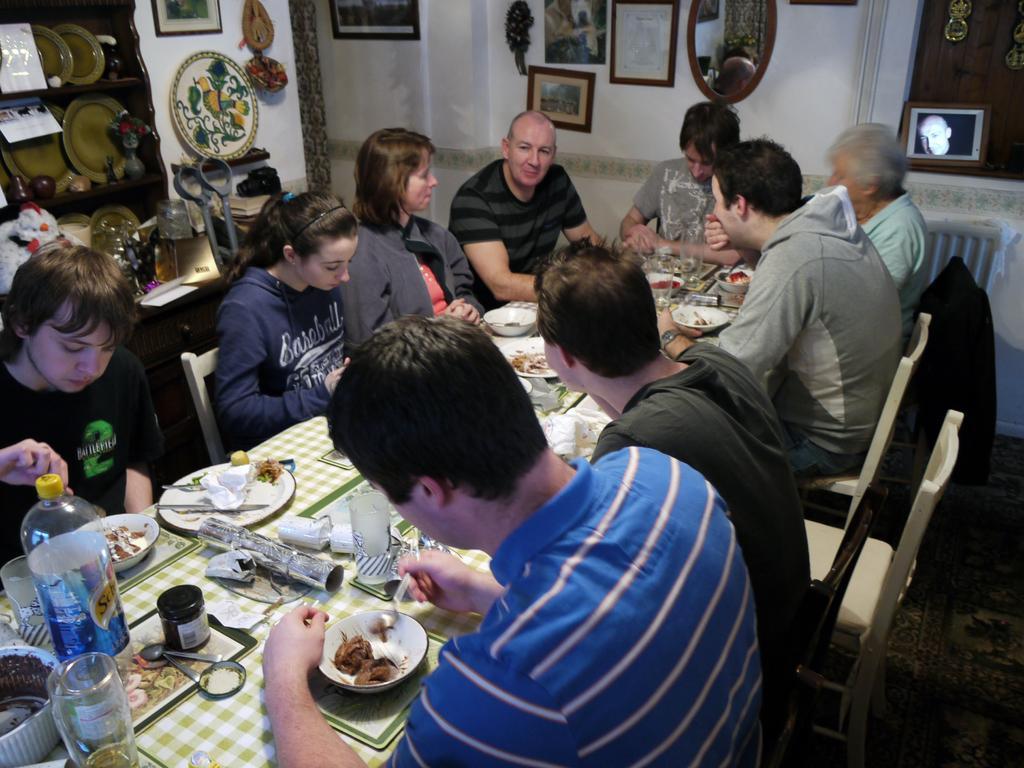In one or two sentences, can you explain what this image depicts? In this image I can see some people are sitting on the chairs around the dining table and having some food. On the table I can see one bottle, glasses, tray, spoons and some bowls. In the background I can see a wall and there are some frames to this wall. In this image there are two women. On the top left of the image I can see a rack containing some papers and plates in it. 